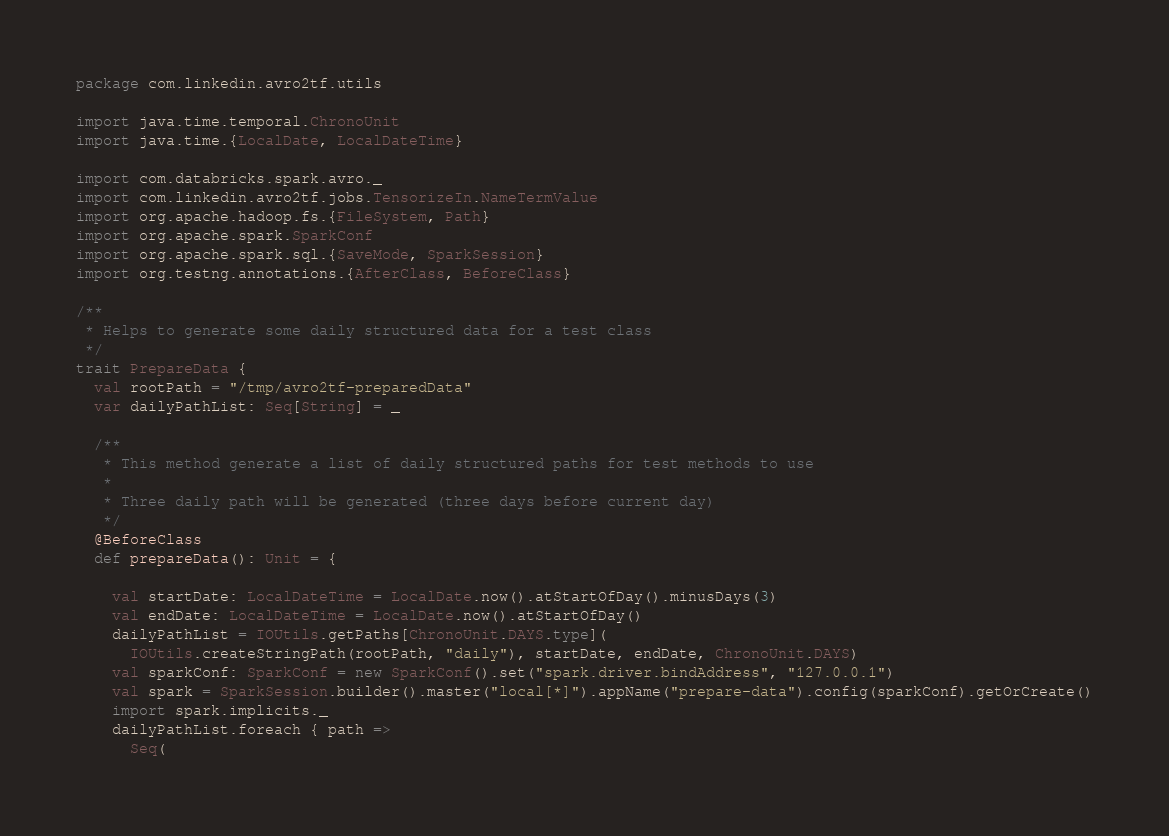<code> <loc_0><loc_0><loc_500><loc_500><_Scala_>package com.linkedin.avro2tf.utils

import java.time.temporal.ChronoUnit
import java.time.{LocalDate, LocalDateTime}

import com.databricks.spark.avro._
import com.linkedin.avro2tf.jobs.TensorizeIn.NameTermValue
import org.apache.hadoop.fs.{FileSystem, Path}
import org.apache.spark.SparkConf
import org.apache.spark.sql.{SaveMode, SparkSession}
import org.testng.annotations.{AfterClass, BeforeClass}

/**
 * Helps to generate some daily structured data for a test class
 */
trait PrepareData {
  val rootPath = "/tmp/avro2tf-preparedData"
  var dailyPathList: Seq[String] = _

  /**
   * This method generate a list of daily structured paths for test methods to use
   *
   * Three daily path will be generated (three days before current day)
   */
  @BeforeClass
  def prepareData(): Unit = {

    val startDate: LocalDateTime = LocalDate.now().atStartOfDay().minusDays(3)
    val endDate: LocalDateTime = LocalDate.now().atStartOfDay()
    dailyPathList = IOUtils.getPaths[ChronoUnit.DAYS.type](
      IOUtils.createStringPath(rootPath, "daily"), startDate, endDate, ChronoUnit.DAYS)
    val sparkConf: SparkConf = new SparkConf().set("spark.driver.bindAddress", "127.0.0.1")
    val spark = SparkSession.builder().master("local[*]").appName("prepare-data").config(sparkConf).getOrCreate()
    import spark.implicits._
    dailyPathList.foreach { path =>
      Seq(</code> 